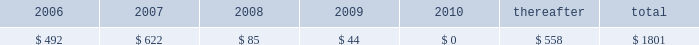Maturities of long-term debt for the five years subsequent to december 31 , 2005 are as follows ( in millions ) : .
Long-term debt payments due in 2006 include $ 350 million of dealer remarketable securities ( final maturity 2010 ) and $ 62 million of medium-term notes ( final maturity 2044 ) .
These securities are classified as current portion of long-term debt as the result of put provisions associated with these debt instruments .
The next date on which investors can require the company to repurchase the convertible notes is 2007 , thus in the above schedule these securities are considered due in 2007 ( final maturity 2032 ) .
The esop debt is serviced by dividends on stock held by the esop and by company contributions .
These contributions are not reported as interest expense , but are reported as an employee benefit expense in the consolidated statement of income .
Other borrowings includes debt held by 3m 2019s international companies and floating rate notes in the united states , with the long-term portion of this debt primarily comprised of u.s .
Dollar floating rate debt .
At december 31 , 2005 , available short-term committed lines of credit globally totaled about $ 618 million , of which $ 101 million was utilized .
Debt covenants do not restrict the payment of dividends .
3m has a medium-term notes program and shelf registration that have remaining capacity of approximately $ 1.438 billion at december 31 , 2005 .
In september 2003 , the company filed a shelf registration statement with the securities and exchange commission relating to the potential offering of debt securities of up to $ 1.5 billion .
This shelf registration became effective in october 2003 .
In december 2003 , the company established under the shelf a medium-term notes program through which up to $ 1.5 billion of medium-term notes may be offered .
3m plans to use the net proceeds from issuances of debt securities under this registration for general corporate purposes , including the repayment of debt ; investments in or extensions of credit to 3m subsidiaries ; or the financing of possible acquisitions or business expansion .
At december 31 , 2004 , $ 62 million of medium-term notes had been issued under the medium-term notes program .
No debt was issued under this program in 2005 .
3m may redeem its 30-year zero-coupon senior notes ( the 201cconvertible notes 201d ) at any time in whole or in part , beginning november 21 , 2007 , at the accreted conversion price ; however , bondholders may convert upon notification of redemption into 9.4602 shares of 3m common stock .
Holders of the 30-year zero-coupon senior notes have the option to require 3m to purchase their notes at accreted value on november 21 in the years 2005 , 2007 , 2012 , 2017 , 2022 and 2027 .
In november 2005 , 22506 of the 639000 in outstanding bonds were redeemed , resulting in a payout from 3m of approximately $ 20 million .
This reduced the convertible notes 2019 face value at maturity to $ 616 million , which equates to a book value of approximately $ 539 million at december 31 , 2005 .
As disclosed in a form 8-k in november 2005 , 3m amended the terms of these securities to pay cash at a rate of 2.40% ( 2.40 % ) per annum of the principal amount at maturity of the company 2019s convertible notes , which equates to 2.75% ( 2.75 % ) per annum of the notes 2019 accreted value on november 21 , 2005 .
The cash interest payments will be made semiannually in arrears on may 22 , 2006 , november 22 , 2006 , may 22 , 2007 and november 22 , 2007 to holders of record on the 15th calendar day preceding each such interest payment date .
3m originally sold $ 639 million in aggregate face amount of these 201cconvertible notes 201d on november 15 , 2002 , which are convertible into shares of 3m common stock .
The gross proceeds from the offering , to be used for general corporate purposes , were $ 550 million ( $ 540 million net of issuance costs ) .
Debt issuance costs were amortized on a straight-line basis over a three-year period beginning in november 2002 .
On february 14 , 2003 , 3m registered these convertible notes in a registration statement filed with the securities and exchange commission .
The terms of the convertible notes include a yield to maturity of .50% ( .50 % ) and an initial conversion premium of 40% ( 40 % ) over the $ 65.00 ( split-adjusted ) closing price of 3m common stock on november 14 , 2002 .
If certain conditions for conversion ( relating to the closing common stock prices of 3m exceeding the conversion trigger price for specified periods ) are met , holders may convert each of the 30-year zero-coupon senior notes into 9.4602 shares of 3m common stock in any calendar quarter commencing after march 31 , 2003 .
The conversion trigger price for the fourth quarter of 2005 was $ 120.00 per share .
If the conditions for conversion are met , and 3m elects not to settle in cash , the 30-year zero-coupon senior notes will be convertible in the aggregate into approximately 5.8 million shares of 3m common stock .
3m may choose to pay the redemption purchase price in cash and/or common stock ; however , if redemption occurs , the company has the intent and ability to settle this debt security in cash .
The conditions for conversion have never been met ; accordingly , there has been no impact on 3m 2019s diluted earnings per share .
For a discussion of accounting pronouncements that will affect accounting treatment for the convertible note , refer to note 1 to the consolidated financial statements for discussion of eitf issue no .
04-08 , 201cthe effect of contingently convertible debt on diluted earnings per share 201d and proposed sfas no .
128r , 201cearnings per share 201d. .
In 2006 what was the ratio of the long-term debt payments due dealer remarketable securities to the medium-term notes? 
Rationale: in 2006 the ratio of the long-term debt payments due dealer remarketable securities to the medium-term notes was 5.65 to 1
Computations: (350 / 62)
Answer: 5.64516. 